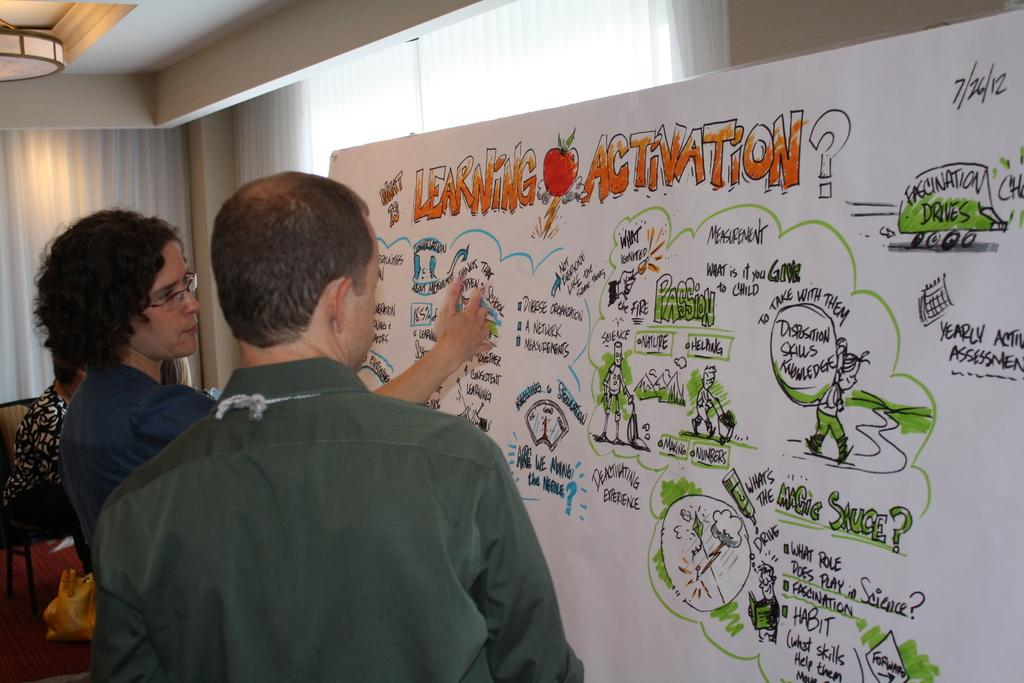What is happening in the foreground of the image? There are people in front of a board in the image. Can you describe the board in the image? The board contains diagrams and text. Is there anything else notable in the background of the image? Yes, there is a woman sitting on a couch in the background of the image. What type of wire can be seen connecting the diagrams on the board? There is no wire connecting the diagrams on the board in the image. Is there a fire visible in the image? No, there is no fire visible in the image. 